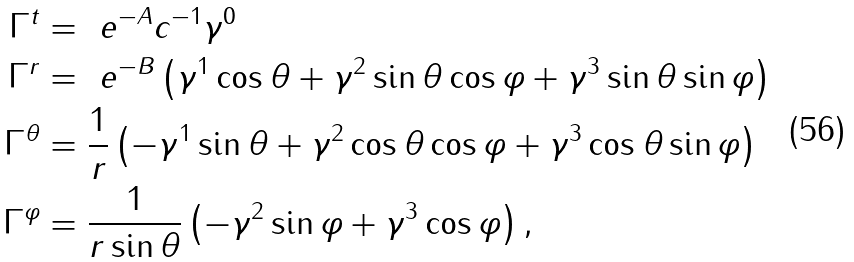Convert formula to latex. <formula><loc_0><loc_0><loc_500><loc_500>\Gamma ^ { t } & = \ e ^ { - A } c ^ { - 1 } \gamma ^ { 0 } \\ \Gamma ^ { r } & = \ e ^ { - B } \left ( \gamma ^ { 1 } \cos \theta + \gamma ^ { 2 } \sin \theta \cos \varphi + \gamma ^ { 3 } \sin \theta \sin \varphi \right ) \\ \Gamma ^ { \theta } & = \frac { 1 } { r } \left ( - \gamma ^ { 1 } \sin \theta + \gamma ^ { 2 } \cos \theta \cos \varphi + \gamma ^ { 3 } \cos \theta \sin \varphi \right ) \\ \Gamma ^ { \varphi } & = \frac { 1 } { r \sin \theta } \left ( - \gamma ^ { 2 } \sin \varphi + \gamma ^ { 3 } \cos \varphi \right ) ,</formula> 